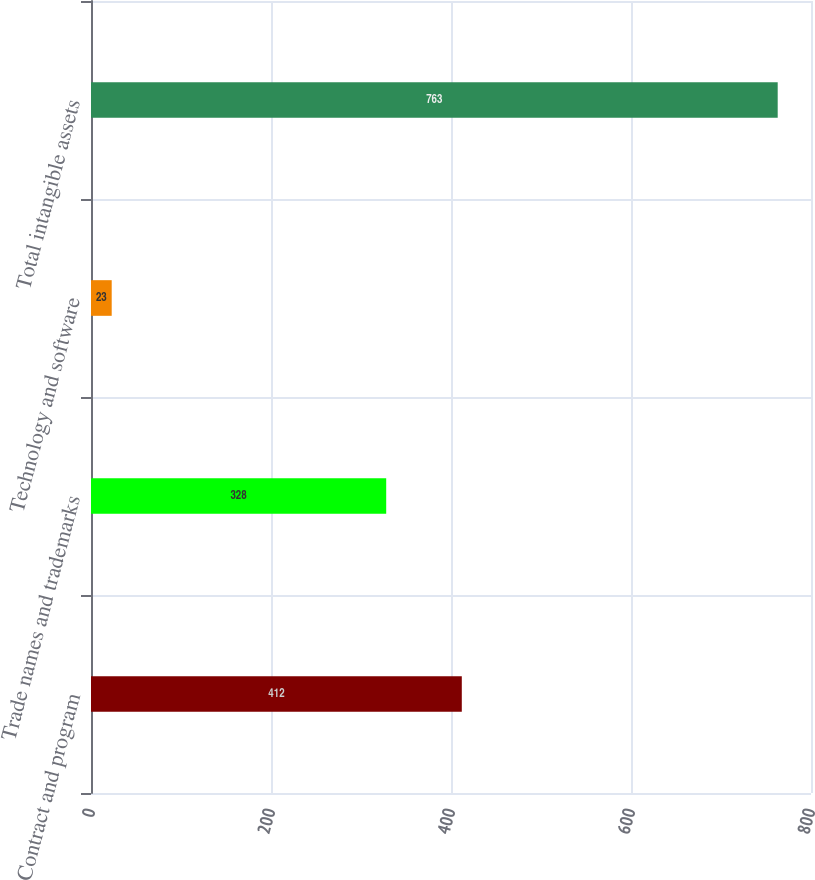Convert chart to OTSL. <chart><loc_0><loc_0><loc_500><loc_500><bar_chart><fcel>Contract and program<fcel>Trade names and trademarks<fcel>Technology and software<fcel>Total intangible assets<nl><fcel>412<fcel>328<fcel>23<fcel>763<nl></chart> 